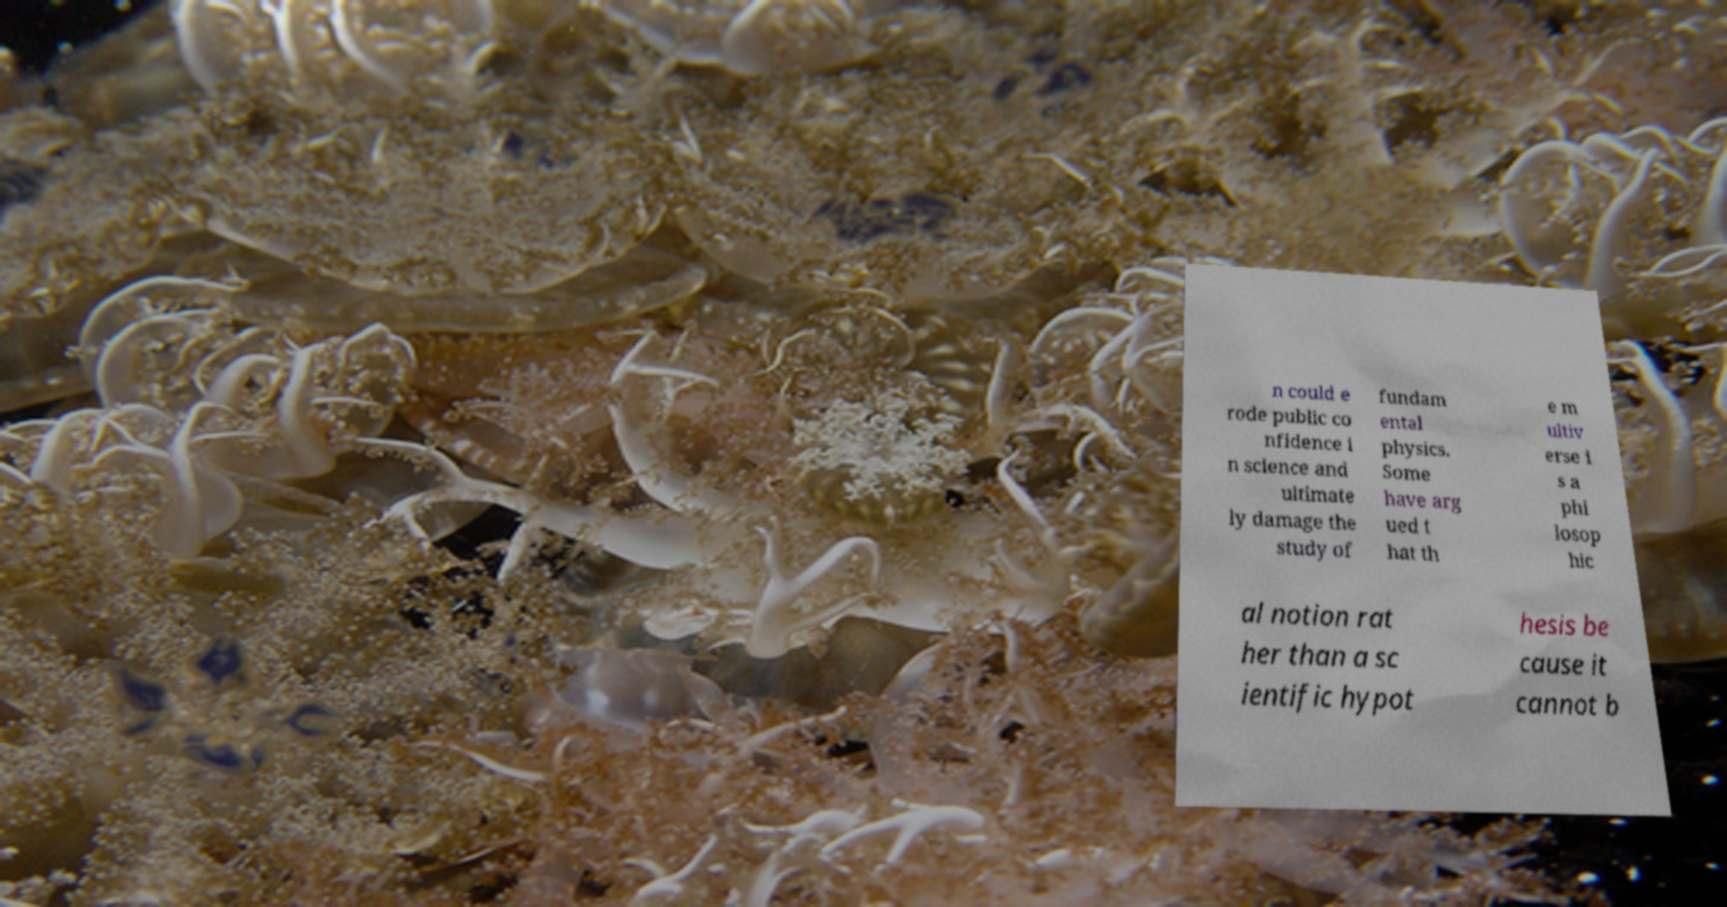Can you read and provide the text displayed in the image?This photo seems to have some interesting text. Can you extract and type it out for me? n could e rode public co nfidence i n science and ultimate ly damage the study of fundam ental physics. Some have arg ued t hat th e m ultiv erse i s a phi losop hic al notion rat her than a sc ientific hypot hesis be cause it cannot b 